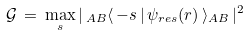Convert formula to latex. <formula><loc_0><loc_0><loc_500><loc_500>\mathcal { G } \, = \, \max _ { s } | \, _ { A B } \langle \, - s \, | \, \psi _ { r e s } ( r ) \, \rangle _ { A B } \, | ^ { 2 }</formula> 